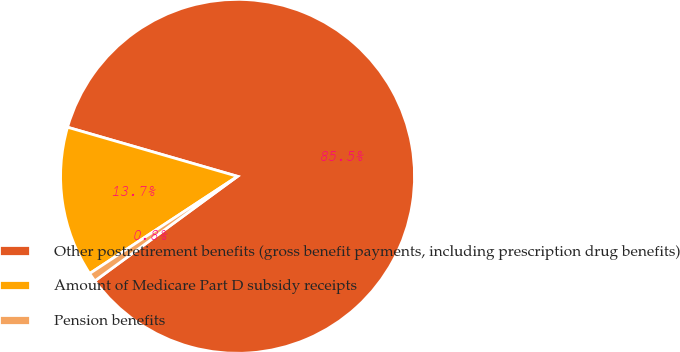<chart> <loc_0><loc_0><loc_500><loc_500><pie_chart><fcel>Other postretirement benefits (gross benefit payments, including prescription drug benefits)<fcel>Amount of Medicare Part D subsidy receipts<fcel>Pension benefits<nl><fcel>85.46%<fcel>13.73%<fcel>0.81%<nl></chart> 